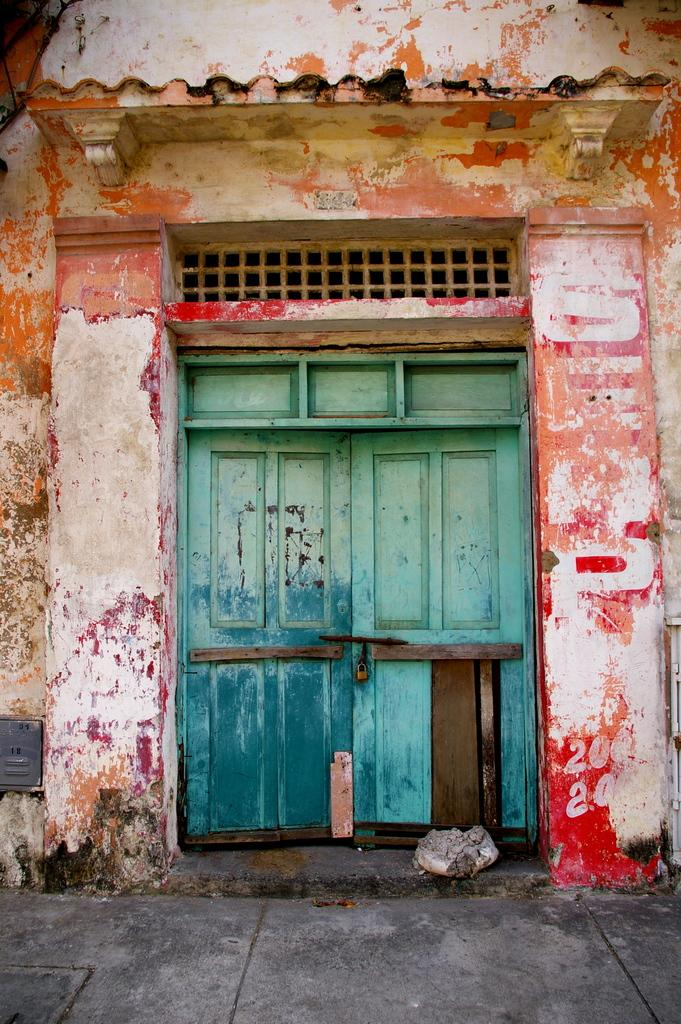What type of door is visible in the image? There is a wooden door in the image. Where is the wooden door located? The wooden door is on a wall. What type of canvas is being used by the crowd in the image? There is no canvas or crowd present in the image; it only features a wooden door on a wall. 